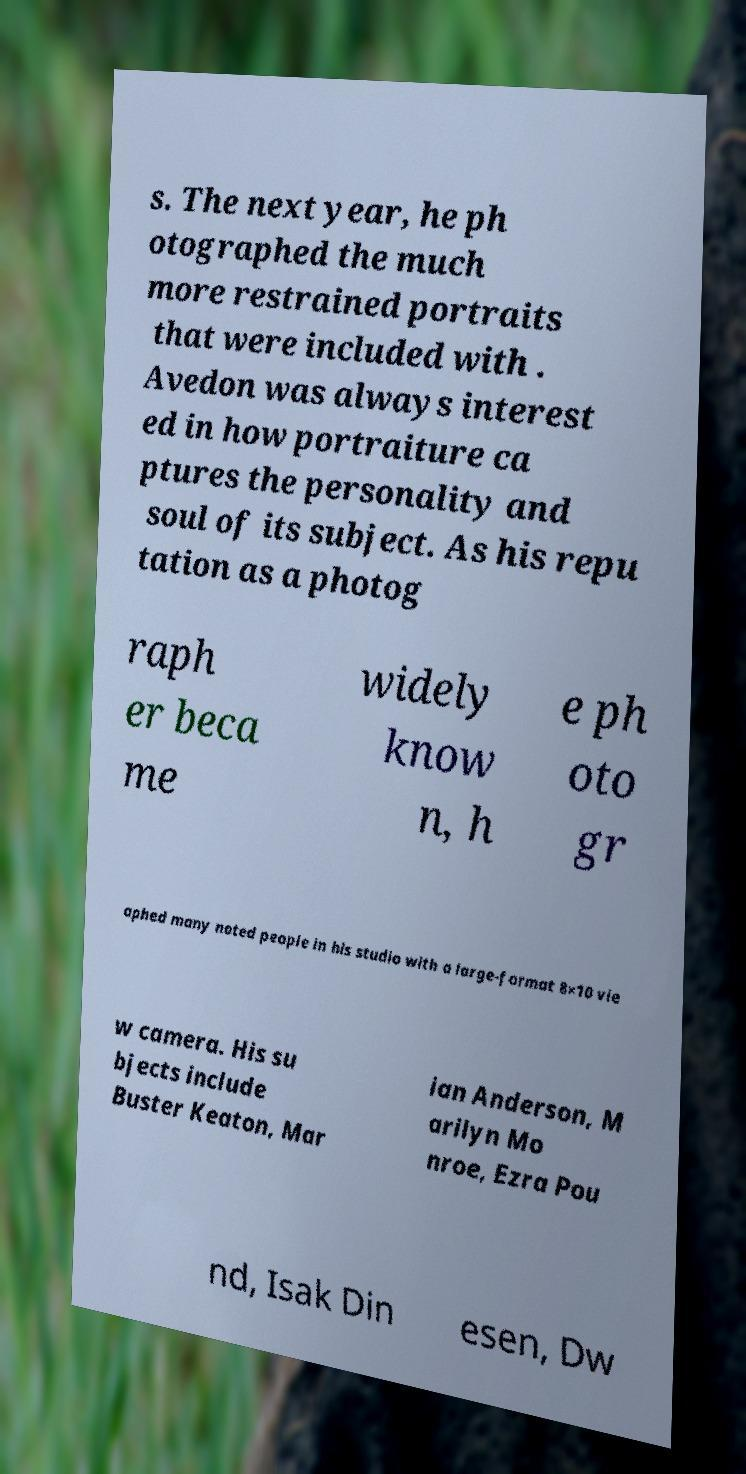I need the written content from this picture converted into text. Can you do that? s. The next year, he ph otographed the much more restrained portraits that were included with . Avedon was always interest ed in how portraiture ca ptures the personality and soul of its subject. As his repu tation as a photog raph er beca me widely know n, h e ph oto gr aphed many noted people in his studio with a large-format 8×10 vie w camera. His su bjects include Buster Keaton, Mar ian Anderson, M arilyn Mo nroe, Ezra Pou nd, Isak Din esen, Dw 